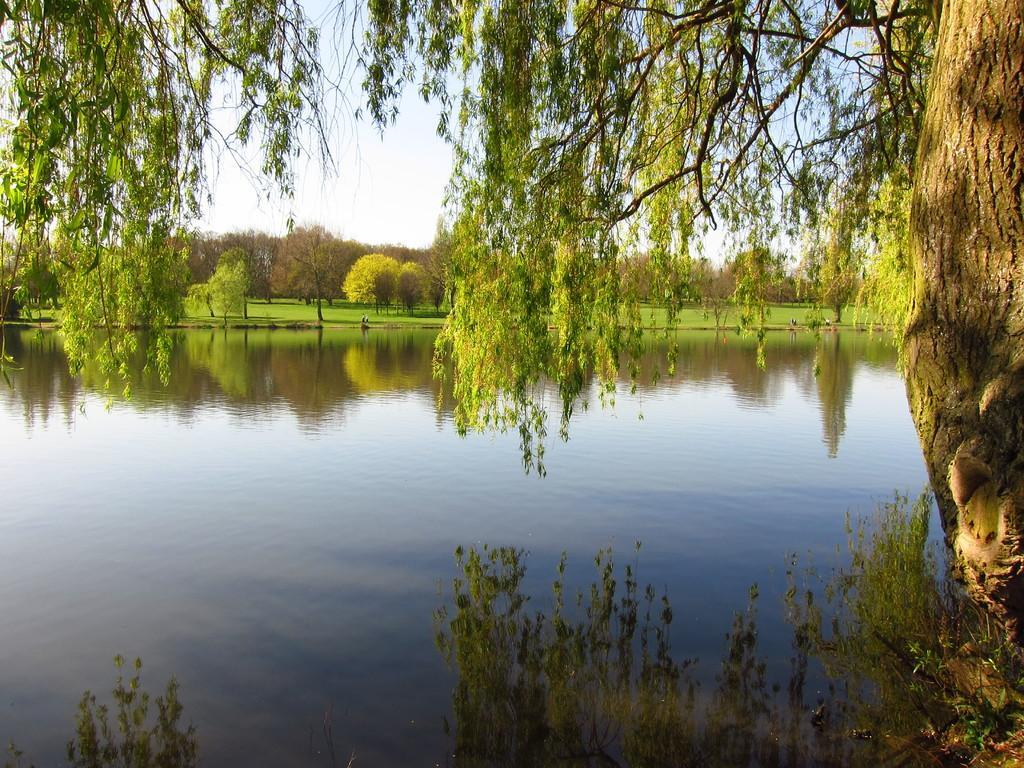In one or two sentences, can you explain what this image depicts? In this image I can see the water and on the surface of the water I can see the reflection of the sky and trees. I can see few trees and in the background I can see few trees which are green and brown in color and the sky. 